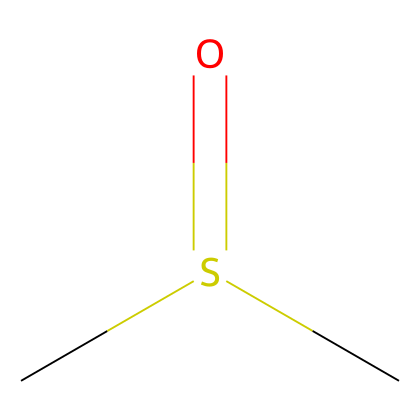What is the molecular formula of this compound? To determine the molecular formula, we count the number of carbon (C), hydrogen (H), oxygen (O), and sulfur (S) atoms from the SMILES representation. There are 2 carbon atoms, 6 hydrogen atoms (as each carbon is usually bonded to 3 hydrogens in such compounds), 1 sulfur atom, and 1 oxygen atom. Thus, the molecular formula is C2H6OS.
Answer: C2H6OS How many hydrogen atoms are present in dimethyl sulfoxide? The structure shows two carbon atoms, each typically bonded to three hydrogen atoms. Hence, with both carbons contributing, there are a total of 6 hydrogen atoms in the molecule.
Answer: 6 What kind of functional group is present in DMSO? In DMSO, the functional group is a sulfoxide, which is characterized by the presence of a sulfur atom double bonded to an oxygen atom (S=O), and has the structure R-S(=O)-R', where R and R' are carbon chains. This highlights its classification.
Answer: sulfoxide Is the sulfur atom in DMSO in a reduced or oxidized state? Sulfur in DMSO is in an oxidized state, often indicated by its bonding with oxygen in a double bond (S=O). Unlike sulfur in lower oxidation states (like in thiols), the presence of an oxygen double bond denotes higher oxidation levels.
Answer: oxidized What is the hybridization of the sulfur atom in DMSO? The hybridization of the sulfur atom in DMSO can be analyzed by considering its bonds. Sulfur forms one double bond with oxygen and single bonds to two carbons, resulting in a steric number of 4 (1 double bond + 2 single bonds + 0 lone pairs). This corresponds to sp3 hybridization.
Answer: sp3 What is the primary use of DMSO in research? DMSO is widely recognized for its role as a solvent that can dissolve both polar and nonpolar compounds, aiding various chemical and biological research applications, including drug formulation, extraction processes, and enhancing solubility of various compounds in reactions.
Answer: versatile solvent 